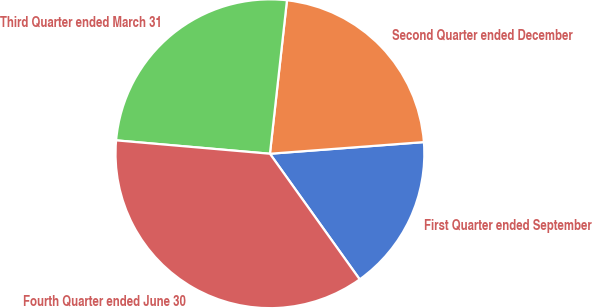<chart> <loc_0><loc_0><loc_500><loc_500><pie_chart><fcel>First Quarter ended September<fcel>Second Quarter ended December<fcel>Third Quarter ended March 31<fcel>Fourth Quarter ended June 30<nl><fcel>16.33%<fcel>22.04%<fcel>25.38%<fcel>36.26%<nl></chart> 